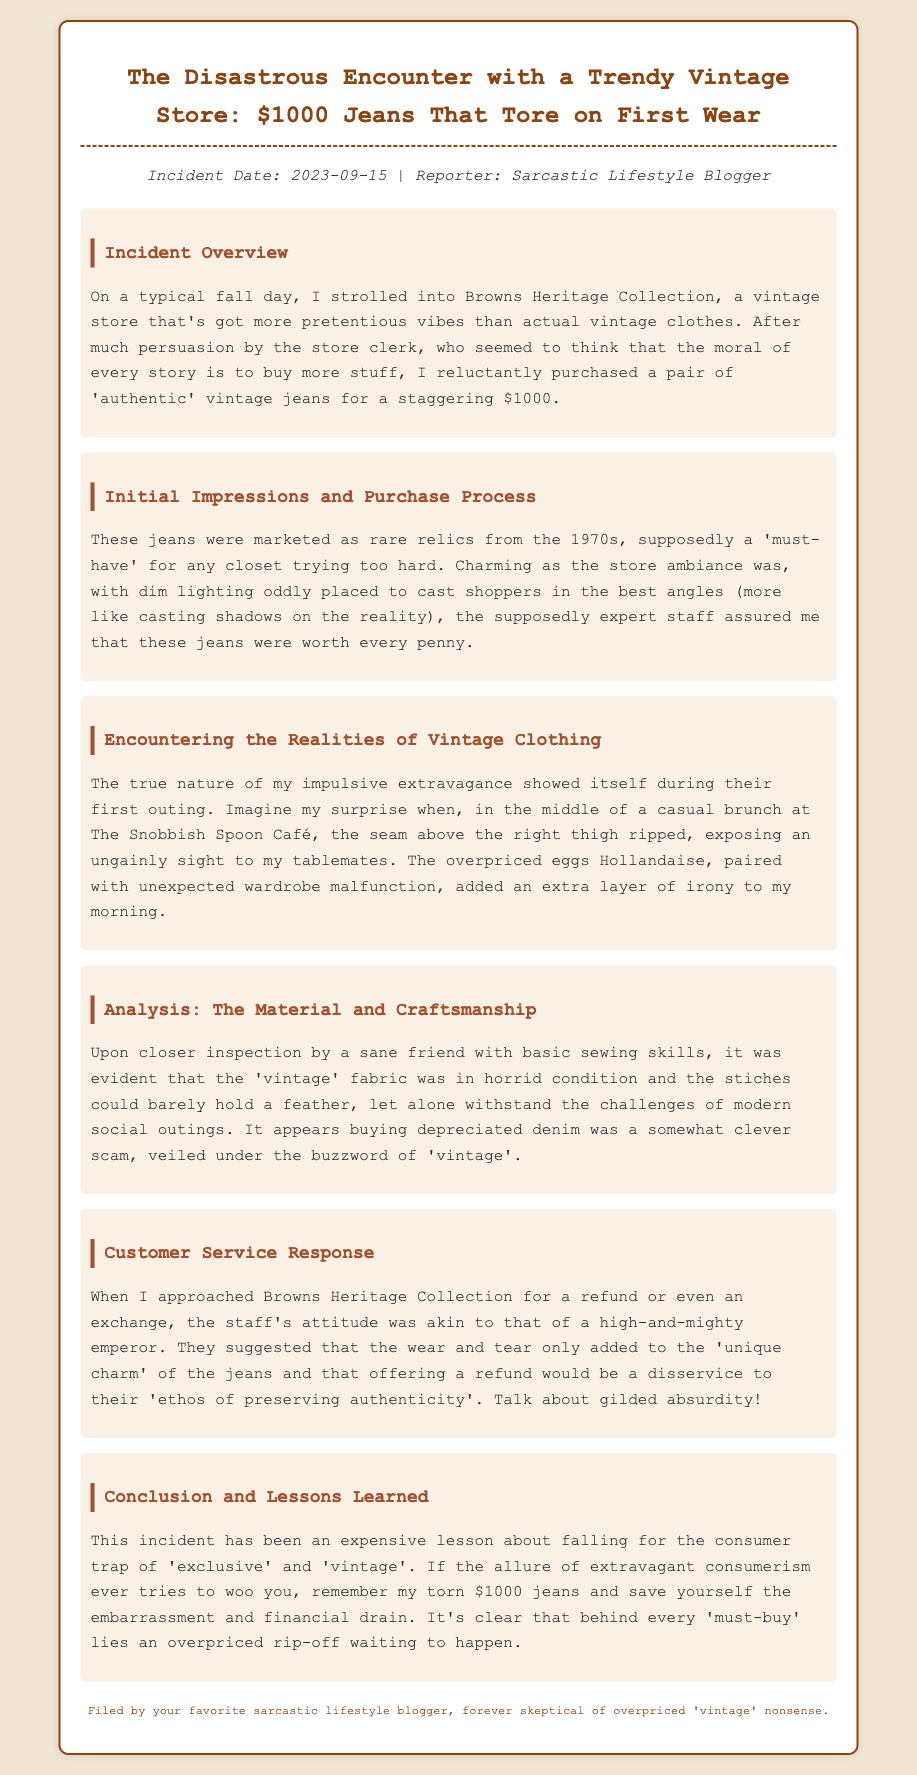What was the incident date? The incident date is mentioned at the beginning of the document.
Answer: 2023-09-15 Where did the encounter take place? The location of the incident is specified in the overview section.
Answer: Browns Heritage Collection How much did the jeans cost? The cost of the jeans is explicitly stated in the document.
Answer: $1000 What happened to the jeans during the first outing? The document describes what occurred when the jeans were worn for the first time.
Answer: The seam ripped What was the reaction of the store staff to the refund request? The staff's attitude toward the refund request is detailed in the customer service response section.
Answer: Unique charm What lesson is emphasized in the conclusion? The conclusion suggests a specific lesson learned from the experience.
Answer: Expensive lesson What is the style of the document? The nature of the document is conveyed by its structure and content.
Answer: Incident report Who filed the report? The name of the individual filing the report is found at the end of the document.
Answer: Sarcastic lifestyle blogger 